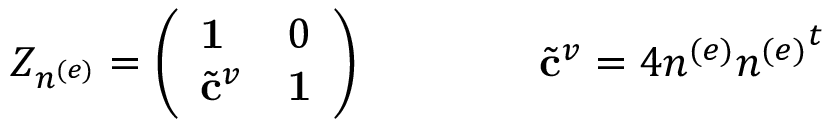<formula> <loc_0><loc_0><loc_500><loc_500>Z _ { n ^ { ( e ) } } = \left ( \begin{array} { l l } { 1 } & { 0 } \\ { { { { \tilde { c } } ^ { v } } } } & { 1 } \end{array} \right ) \quad { \tilde { c } } ^ { v } = 4 n ^ { ( e ) } { n ^ { ( e ) } } ^ { t }</formula> 